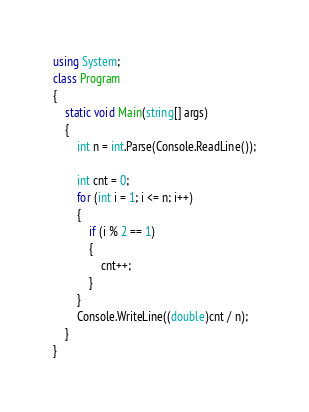<code> <loc_0><loc_0><loc_500><loc_500><_C#_>using System;
class Program
{
    static void Main(string[] args)
    {
        int n = int.Parse(Console.ReadLine());

        int cnt = 0;
        for (int i = 1; i <= n; i++)
        {
            if (i % 2 == 1)
            {
                cnt++;
            }
        }
        Console.WriteLine((double)cnt / n);
    }
}</code> 